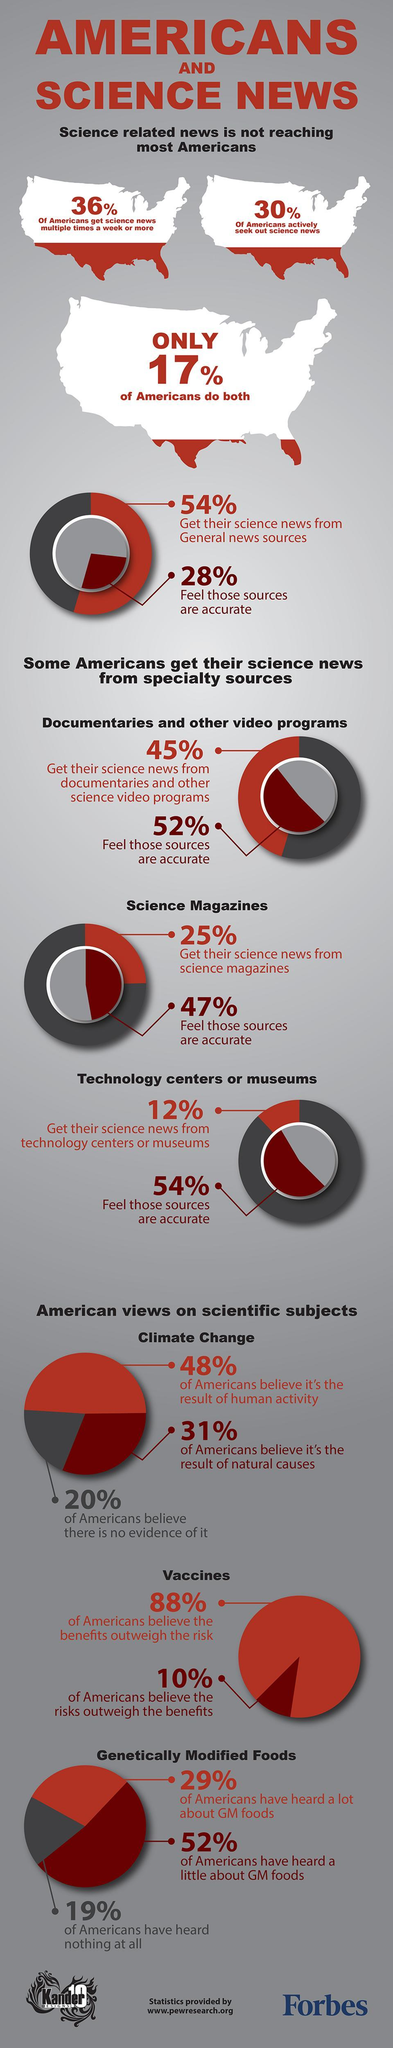Give some essential details in this illustration. A recent survey reveals that 31% of Americans believe that climate change is caused by natural factors, rather than human activity. According to a recent survey, 30% of Americans actively seek out science news. According to a recent survey, 19% of Americans reported not having heard about genetically modified foods. 